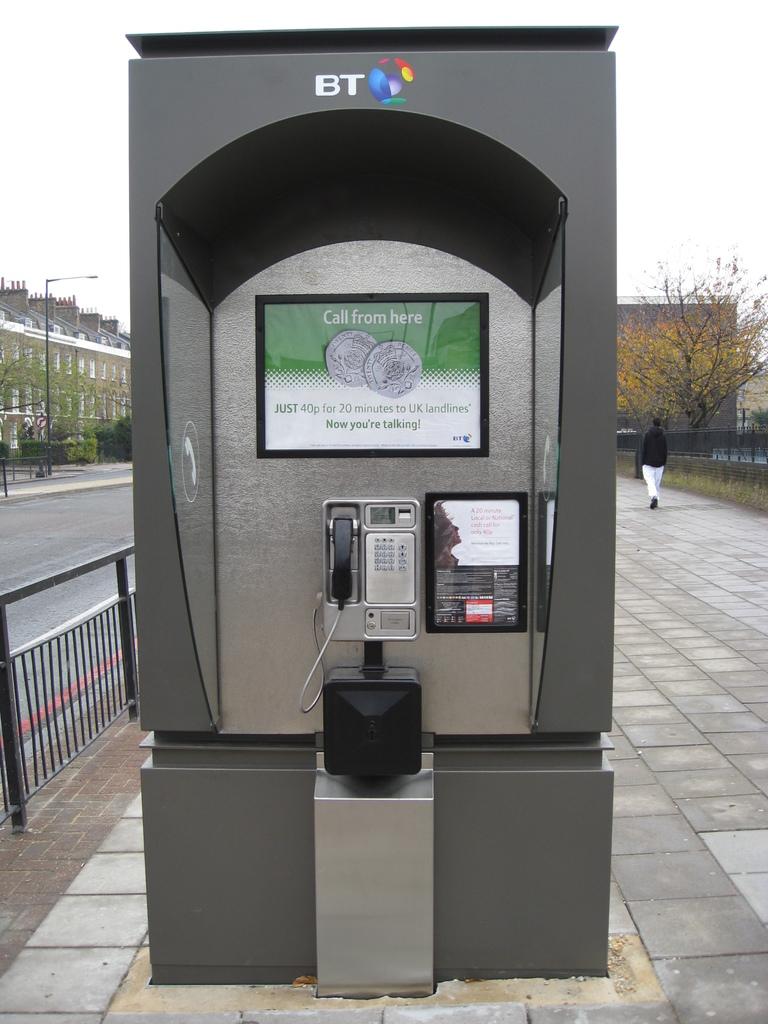How much is a 20 minute call?
Your answer should be compact. 40p. What is the name of the machine?
Your response must be concise. Bt. 